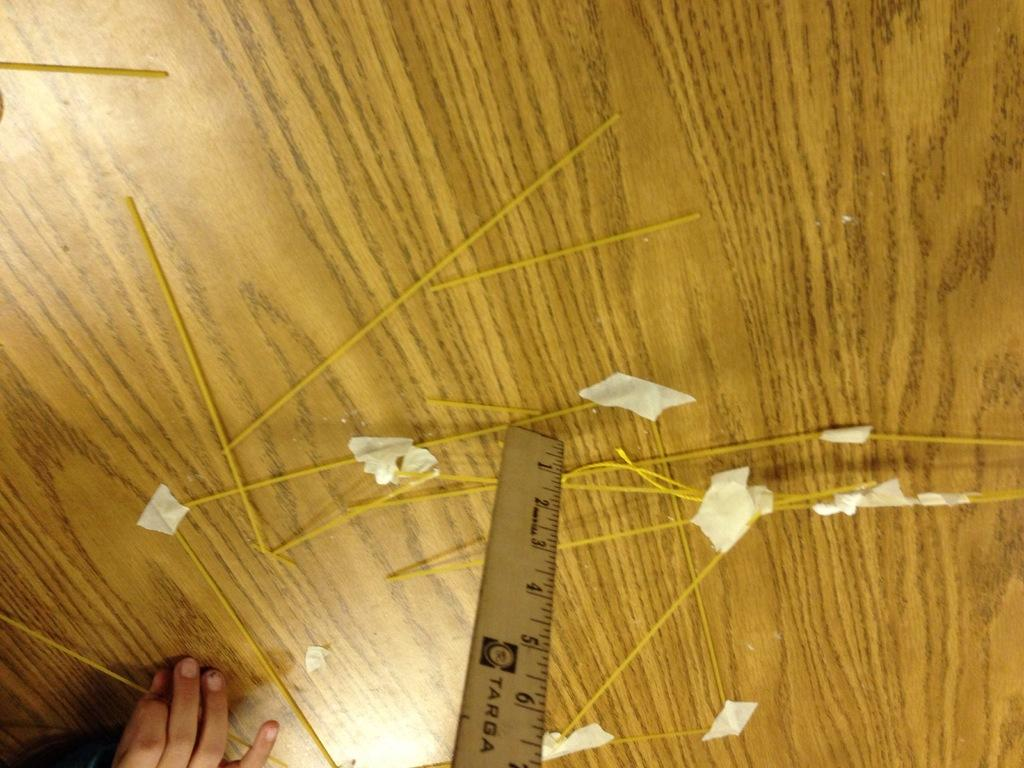<image>
Describe the image concisely. A person is using a targa ruler on a wooden table top 